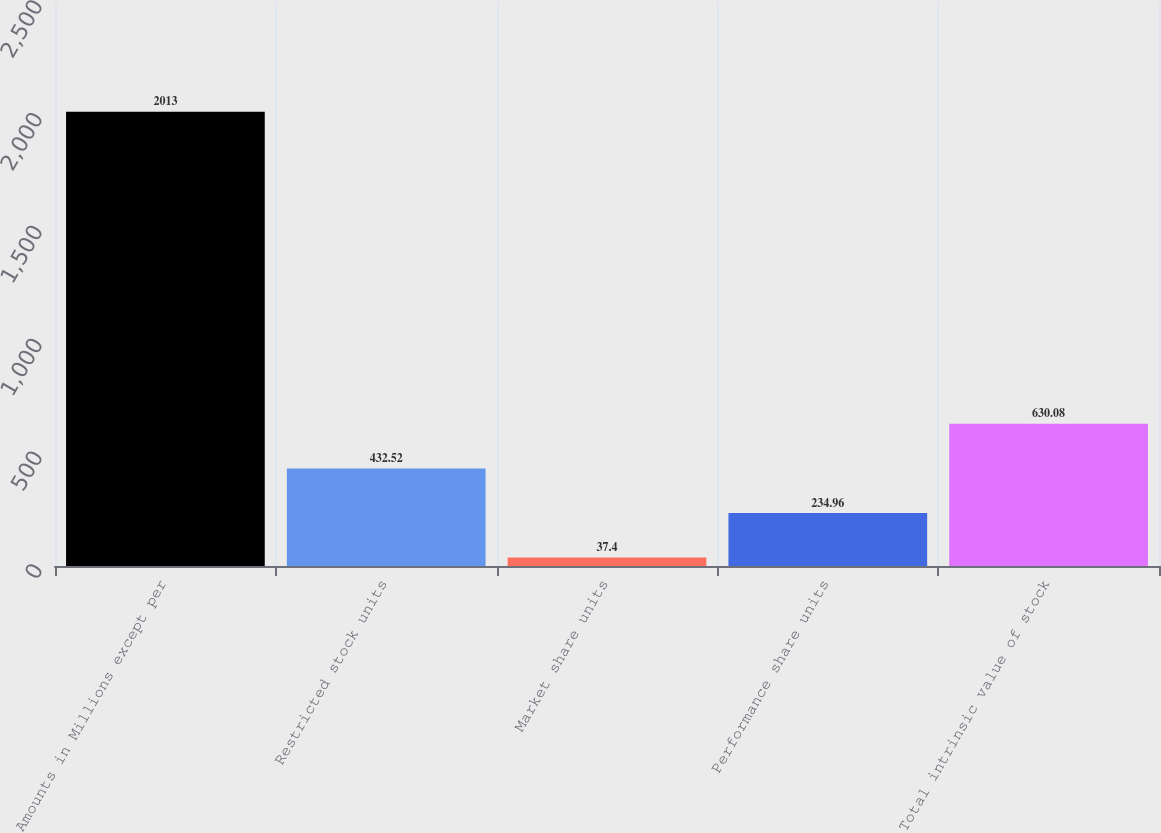Convert chart. <chart><loc_0><loc_0><loc_500><loc_500><bar_chart><fcel>Amounts in Millions except per<fcel>Restricted stock units<fcel>Market share units<fcel>Performance share units<fcel>Total intrinsic value of stock<nl><fcel>2013<fcel>432.52<fcel>37.4<fcel>234.96<fcel>630.08<nl></chart> 